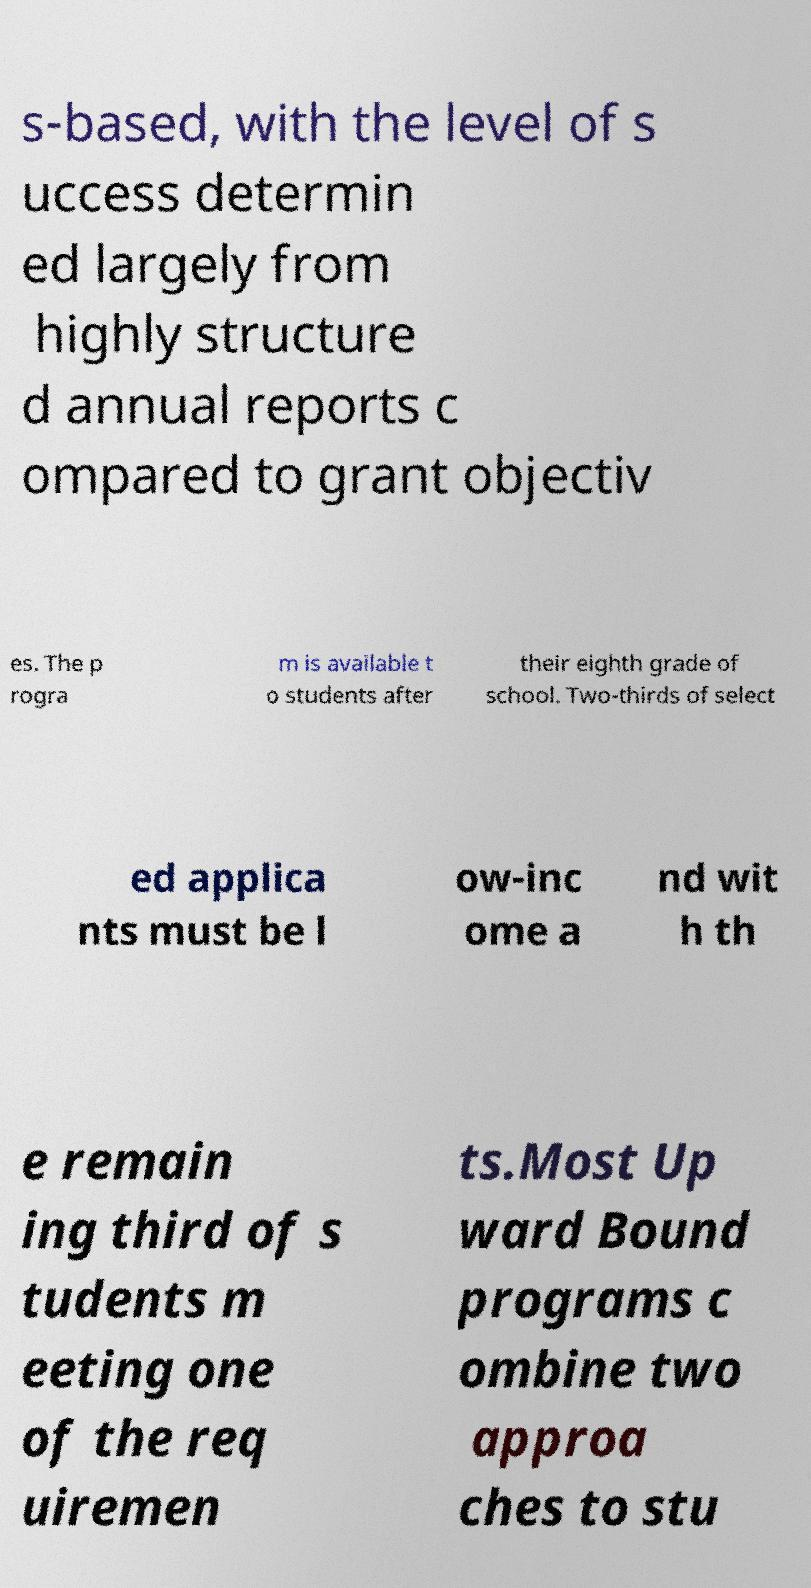What messages or text are displayed in this image? I need them in a readable, typed format. s-based, with the level of s uccess determin ed largely from highly structure d annual reports c ompared to grant objectiv es. The p rogra m is available t o students after their eighth grade of school. Two-thirds of select ed applica nts must be l ow-inc ome a nd wit h th e remain ing third of s tudents m eeting one of the req uiremen ts.Most Up ward Bound programs c ombine two approa ches to stu 